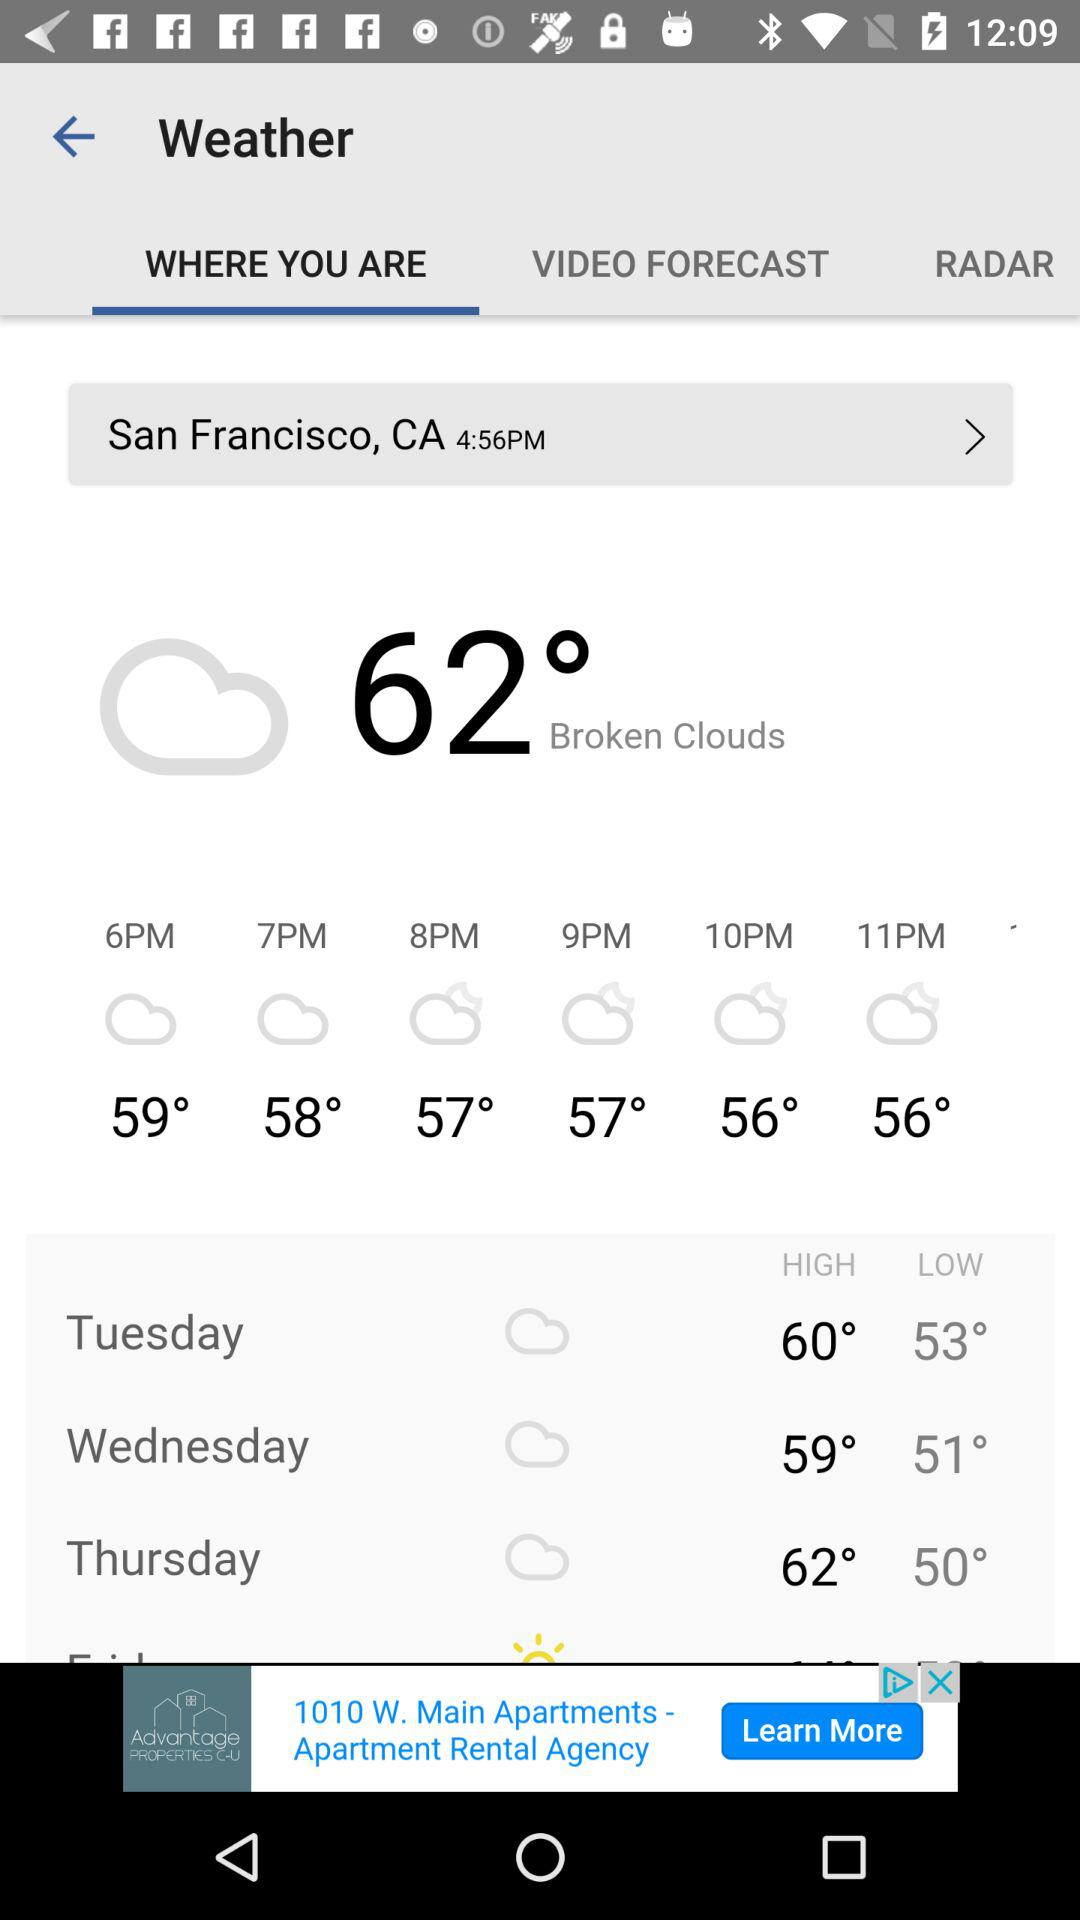What is the low temperature on Tuesday? The low temperature on Tuesday is 53 degrees. 